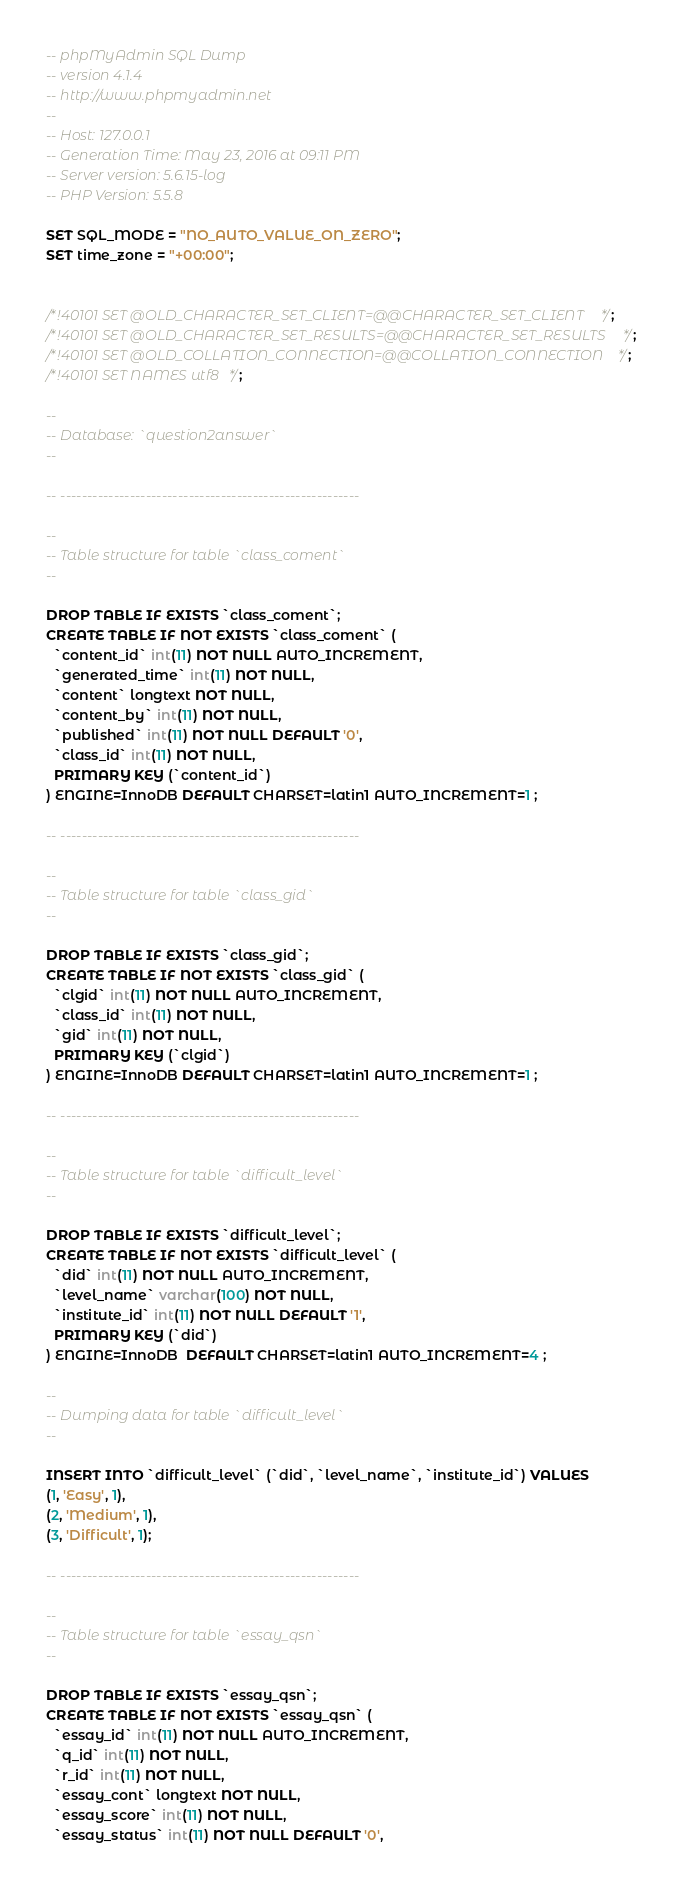<code> <loc_0><loc_0><loc_500><loc_500><_SQL_>-- phpMyAdmin SQL Dump
-- version 4.1.4
-- http://www.phpmyadmin.net
--
-- Host: 127.0.0.1
-- Generation Time: May 23, 2016 at 09:11 PM
-- Server version: 5.6.15-log
-- PHP Version: 5.5.8

SET SQL_MODE = "NO_AUTO_VALUE_ON_ZERO";
SET time_zone = "+00:00";


/*!40101 SET @OLD_CHARACTER_SET_CLIENT=@@CHARACTER_SET_CLIENT */;
/*!40101 SET @OLD_CHARACTER_SET_RESULTS=@@CHARACTER_SET_RESULTS */;
/*!40101 SET @OLD_COLLATION_CONNECTION=@@COLLATION_CONNECTION */;
/*!40101 SET NAMES utf8 */;

--
-- Database: `question2answer`
--

-- --------------------------------------------------------

--
-- Table structure for table `class_coment`
--

DROP TABLE IF EXISTS `class_coment`;
CREATE TABLE IF NOT EXISTS `class_coment` (
  `content_id` int(11) NOT NULL AUTO_INCREMENT,
  `generated_time` int(11) NOT NULL,
  `content` longtext NOT NULL,
  `content_by` int(11) NOT NULL,
  `published` int(11) NOT NULL DEFAULT '0',
  `class_id` int(11) NOT NULL,
  PRIMARY KEY (`content_id`)
) ENGINE=InnoDB DEFAULT CHARSET=latin1 AUTO_INCREMENT=1 ;

-- --------------------------------------------------------

--
-- Table structure for table `class_gid`
--

DROP TABLE IF EXISTS `class_gid`;
CREATE TABLE IF NOT EXISTS `class_gid` (
  `clgid` int(11) NOT NULL AUTO_INCREMENT,
  `class_id` int(11) NOT NULL,
  `gid` int(11) NOT NULL,
  PRIMARY KEY (`clgid`)
) ENGINE=InnoDB DEFAULT CHARSET=latin1 AUTO_INCREMENT=1 ;

-- --------------------------------------------------------

--
-- Table structure for table `difficult_level`
--

DROP TABLE IF EXISTS `difficult_level`;
CREATE TABLE IF NOT EXISTS `difficult_level` (
  `did` int(11) NOT NULL AUTO_INCREMENT,
  `level_name` varchar(100) NOT NULL,
  `institute_id` int(11) NOT NULL DEFAULT '1',
  PRIMARY KEY (`did`)
) ENGINE=InnoDB  DEFAULT CHARSET=latin1 AUTO_INCREMENT=4 ;

--
-- Dumping data for table `difficult_level`
--

INSERT INTO `difficult_level` (`did`, `level_name`, `institute_id`) VALUES
(1, 'Easy', 1),
(2, 'Medium', 1),
(3, 'Difficult', 1);

-- --------------------------------------------------------

--
-- Table structure for table `essay_qsn`
--

DROP TABLE IF EXISTS `essay_qsn`;
CREATE TABLE IF NOT EXISTS `essay_qsn` (
  `essay_id` int(11) NOT NULL AUTO_INCREMENT,
  `q_id` int(11) NOT NULL,
  `r_id` int(11) NOT NULL,
  `essay_cont` longtext NOT NULL,
  `essay_score` int(11) NOT NULL,
  `essay_status` int(11) NOT NULL DEFAULT '0',</code> 